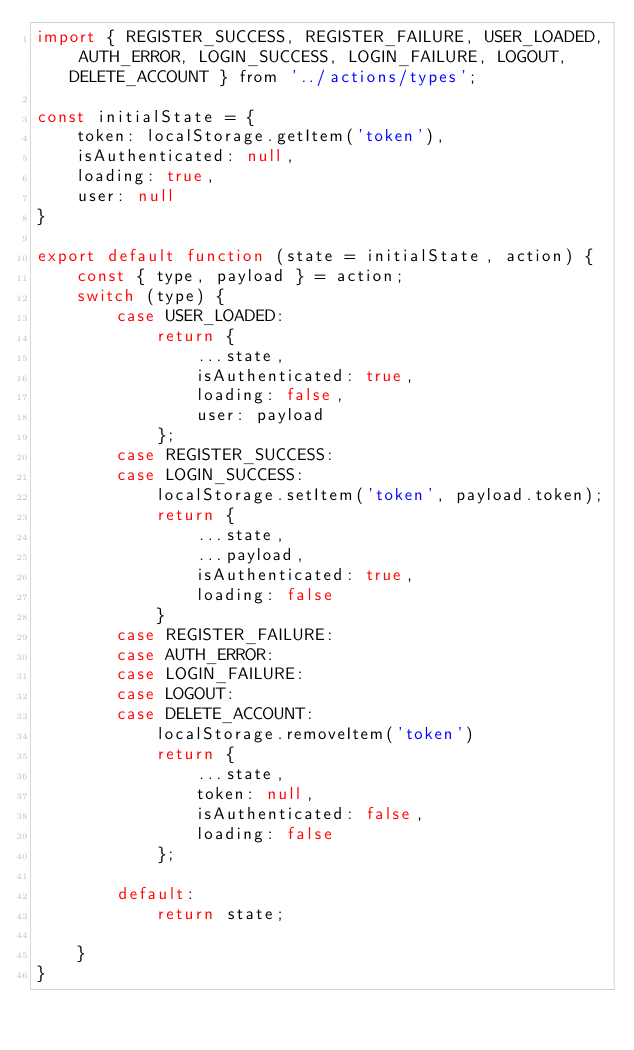<code> <loc_0><loc_0><loc_500><loc_500><_JavaScript_>import { REGISTER_SUCCESS, REGISTER_FAILURE, USER_LOADED, AUTH_ERROR, LOGIN_SUCCESS, LOGIN_FAILURE, LOGOUT, DELETE_ACCOUNT } from '../actions/types';

const initialState = {
    token: localStorage.getItem('token'),
    isAuthenticated: null,
    loading: true,
    user: null
}

export default function (state = initialState, action) {
    const { type, payload } = action;
    switch (type) {
        case USER_LOADED:
            return {
                ...state,
                isAuthenticated: true,
                loading: false,
                user: payload
            };
        case REGISTER_SUCCESS:
        case LOGIN_SUCCESS:
            localStorage.setItem('token', payload.token);
            return {
                ...state,
                ...payload,
                isAuthenticated: true,
                loading: false
            }
        case REGISTER_FAILURE:
        case AUTH_ERROR:
        case LOGIN_FAILURE:
        case LOGOUT:
        case DELETE_ACCOUNT:
            localStorage.removeItem('token')
            return {
                ...state,
                token: null,
                isAuthenticated: false,
                loading: false
            };

        default:
            return state;

    }
}</code> 